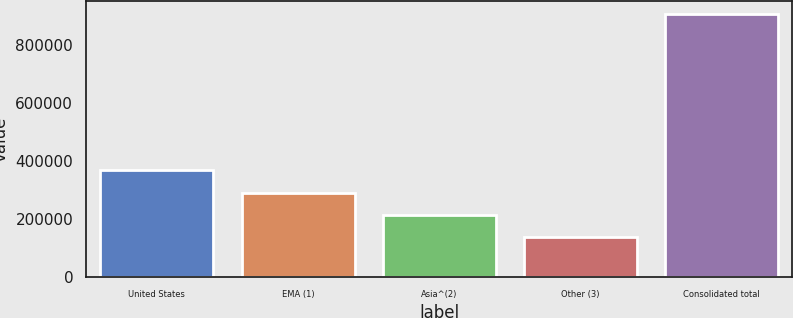Convert chart. <chart><loc_0><loc_0><loc_500><loc_500><bar_chart><fcel>United States<fcel>EMA (1)<fcel>Asia^(2)<fcel>Other (3)<fcel>Consolidated total<nl><fcel>367853<fcel>290699<fcel>213545<fcel>136391<fcel>907931<nl></chart> 